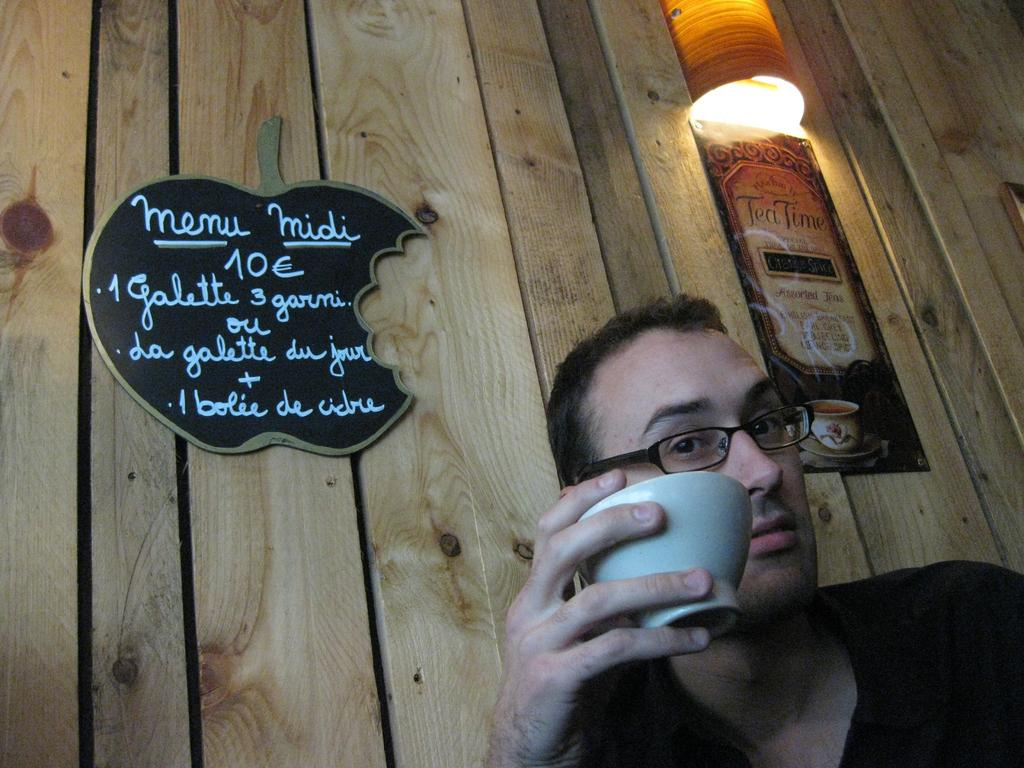Where is the person located in the image? The person is on the right side bottom of the image. What is the person holding in the image? The person is holding a bowl in the image. What accessory is the person wearing in the image? The person is wearing glasses in the image. What type of object can be seen in the background of the image? There is a wooden object in the background of the image. What type of wall decoration is present in the image? There is a poster in the image. What type of flat surface is present in the image? There is a board in the image. What source of light is visible in the image? There is a light in the image. How many boys are carrying a parcel across the bridge in the image? There is no bridge, parcel, or boys present in the image. 